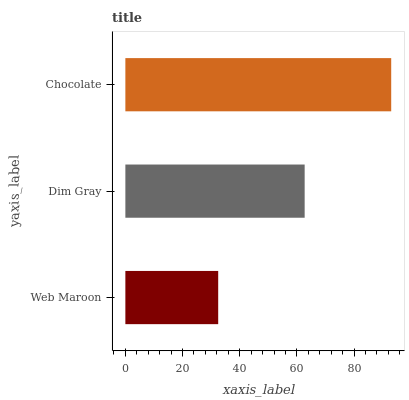Is Web Maroon the minimum?
Answer yes or no. Yes. Is Chocolate the maximum?
Answer yes or no. Yes. Is Dim Gray the minimum?
Answer yes or no. No. Is Dim Gray the maximum?
Answer yes or no. No. Is Dim Gray greater than Web Maroon?
Answer yes or no. Yes. Is Web Maroon less than Dim Gray?
Answer yes or no. Yes. Is Web Maroon greater than Dim Gray?
Answer yes or no. No. Is Dim Gray less than Web Maroon?
Answer yes or no. No. Is Dim Gray the high median?
Answer yes or no. Yes. Is Dim Gray the low median?
Answer yes or no. Yes. Is Web Maroon the high median?
Answer yes or no. No. Is Chocolate the low median?
Answer yes or no. No. 